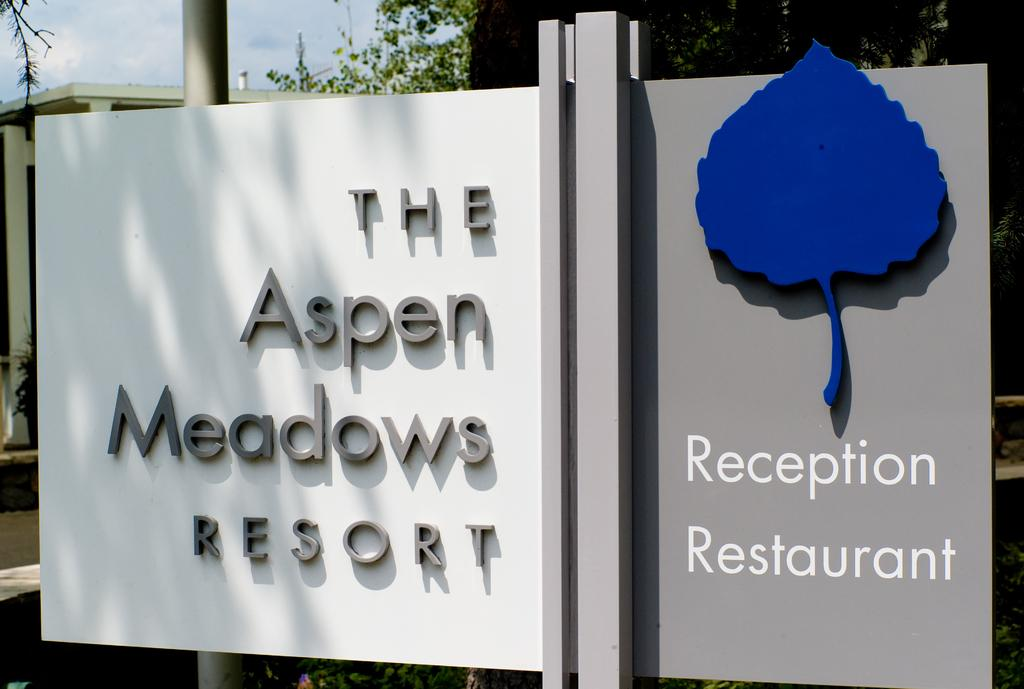What is hanging in the image? There is a banner in the image. What supports the banner? There are poles visible behind the banner. What can be seen in the distance in the image? There are trees and buildings in the background of the image. What is visible in the sky at the top left corner of the image? Clouds are present in the sky at the top left corner of the image. What type of stem can be seen growing from the banner in the image? There is no stem growing from the banner in the image. What color is the celery used to paint the banner in the image? There is no celery or painting involved in the image; it features a banner with a design or text. 